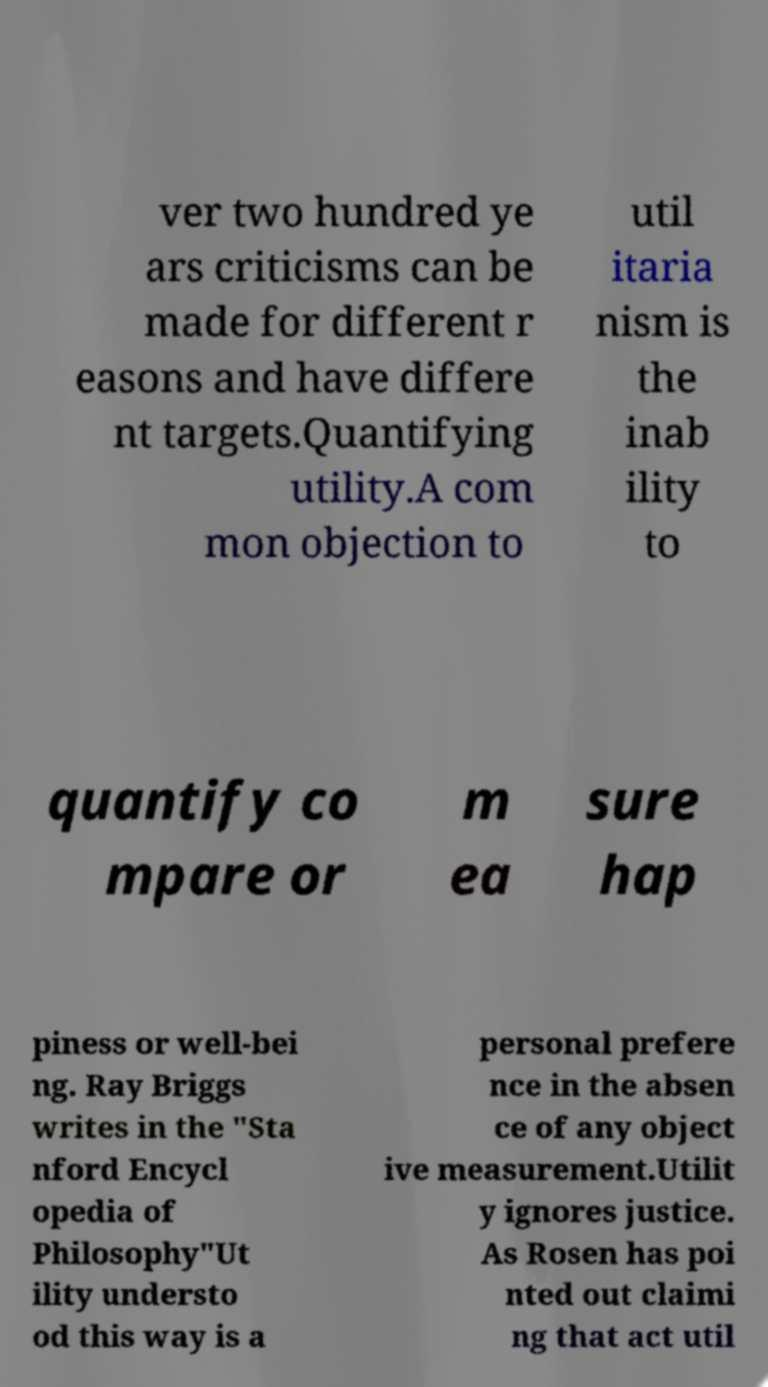For documentation purposes, I need the text within this image transcribed. Could you provide that? ver two hundred ye ars criticisms can be made for different r easons and have differe nt targets.Quantifying utility.A com mon objection to util itaria nism is the inab ility to quantify co mpare or m ea sure hap piness or well-bei ng. Ray Briggs writes in the "Sta nford Encycl opedia of Philosophy"Ut ility understo od this way is a personal prefere nce in the absen ce of any object ive measurement.Utilit y ignores justice. As Rosen has poi nted out claimi ng that act util 